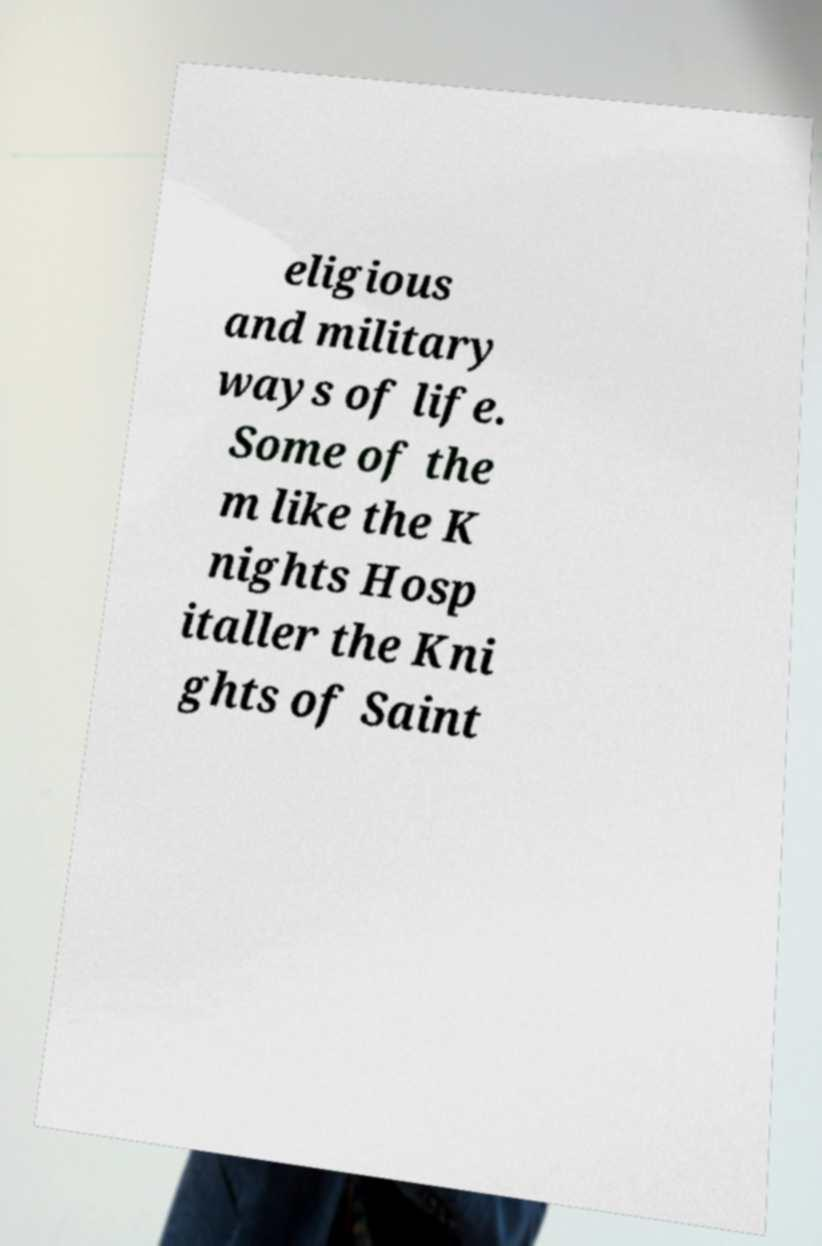What messages or text are displayed in this image? I need them in a readable, typed format. eligious and military ways of life. Some of the m like the K nights Hosp italler the Kni ghts of Saint 